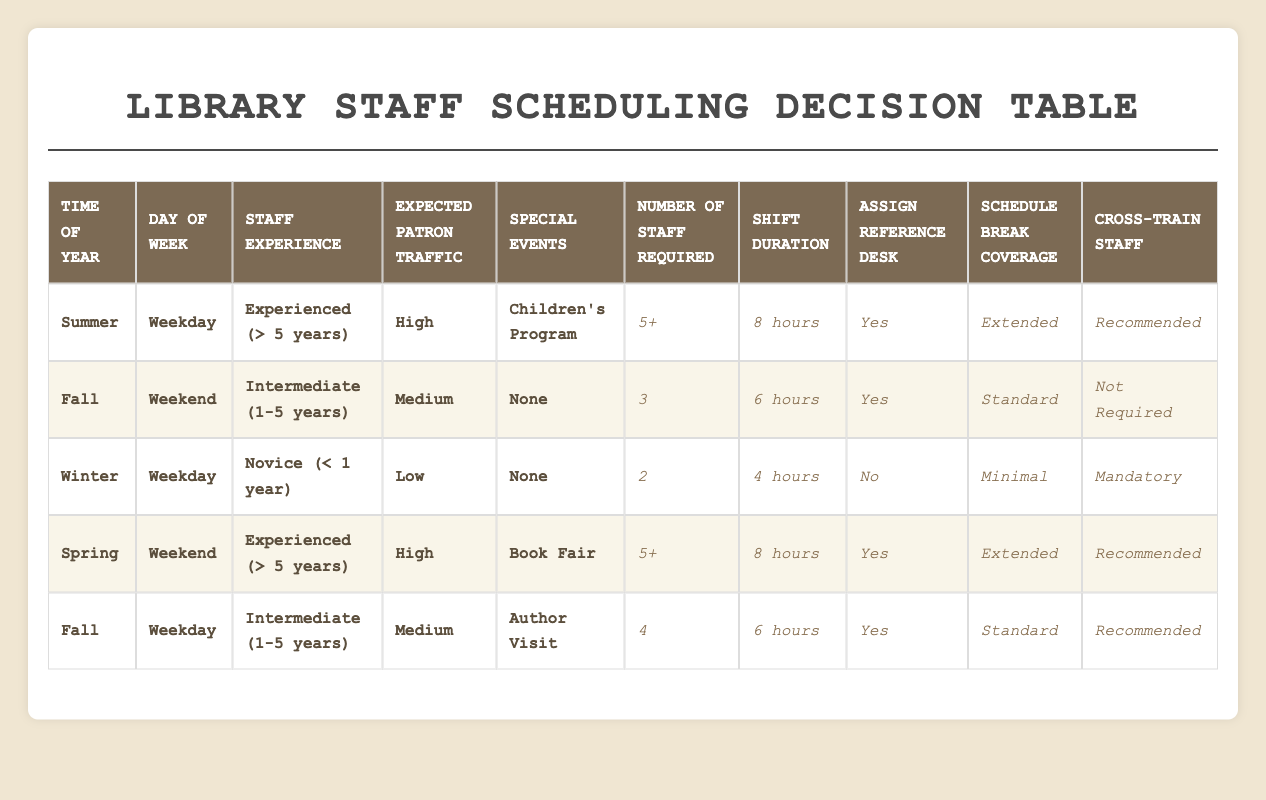What is the maximum number of staff required during any scenario in the table? The maximum number of staff required is 5+, which appears in both the Summer (Children's Program) and Spring (Book Fair) scenarios.
Answer: 5+ During which time of year is break coverage most commonly scheduled as "Extended"? Break coverage is scheduled as "Extended" during the Summer and Spring scenarios. This is also in combination with high expected patron traffic and special events such as a Children's Program or a Book Fair, which indicates busier times needing more staff support.
Answer: Summer, Spring Is cross-training staff mandatory in any of the scenarios? Yes, cross-training staff is mandatory during the Winter scenario (Novice staff, Low traffic, No special events). This highlights the need for novice staff to gain additional training during a relatively low activity period.
Answer: Yes What is the average shift duration across the different scenarios in the table? The shift durations in the scenarios are 8 hours (2 times), 6 hours (3 times), and 4 hours (1 time). To find the average: (8 + 8 + 6 + 6 + 4) / 5 = 6.4 hours, rounded gives an average of 6 hours.
Answer: 6 hours On which day of the week is reference desk assignment least likely? The reference desk is assigned "No" during the Winter scenario (Novice, Low traffic, No special events), making it the only scenario where this occurs.
Answer: Weekday How many scenarios require 4 hours of shift duration, and what factors influence it? Only one scenario requires 4 hours of shift duration, which occurs in Winter (Novice, Low traffic, No special events). The factors of low expected traffic and the experience level of staff contribute to this shorter shift duration.
Answer: 1 What is the condition for scheduling "Minimal" break coverage? "Minimal" break coverage is scheduled when it is Winter, on a Weekday, with Novice staff, Low expected traffic, and no special events. This indicates a quieter time where fewer break coverages are needed due to lower patron interaction.
Answer: Winter, Weekday Are there any scenarios with no special events scheduled where staff experience affects the number of staff required? Yes, in the Winter scenario, staff experience affects the staff count; it requires only 2 staff because both experience and expected patron traffic factors are low.
Answer: Yes How does the expected patron traffic influence the number of staff required during weekends? On weekends, when the expected patron traffic is High, as seen in Spring (5+ staff required), more experienced staff are available to manage the higher traffic demands compared to when it is Medium in Fall (3 staff required), which helps illustrate the direct correlation between traffic expectations and staffing needs.
Answer: 5+, 3 